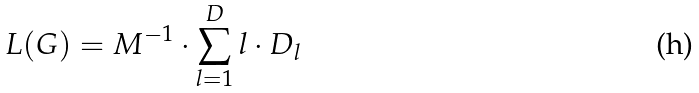Convert formula to latex. <formula><loc_0><loc_0><loc_500><loc_500>L ( G ) = M ^ { - 1 } \cdot \sum _ { l = 1 } ^ { D } l \cdot D _ { l }</formula> 